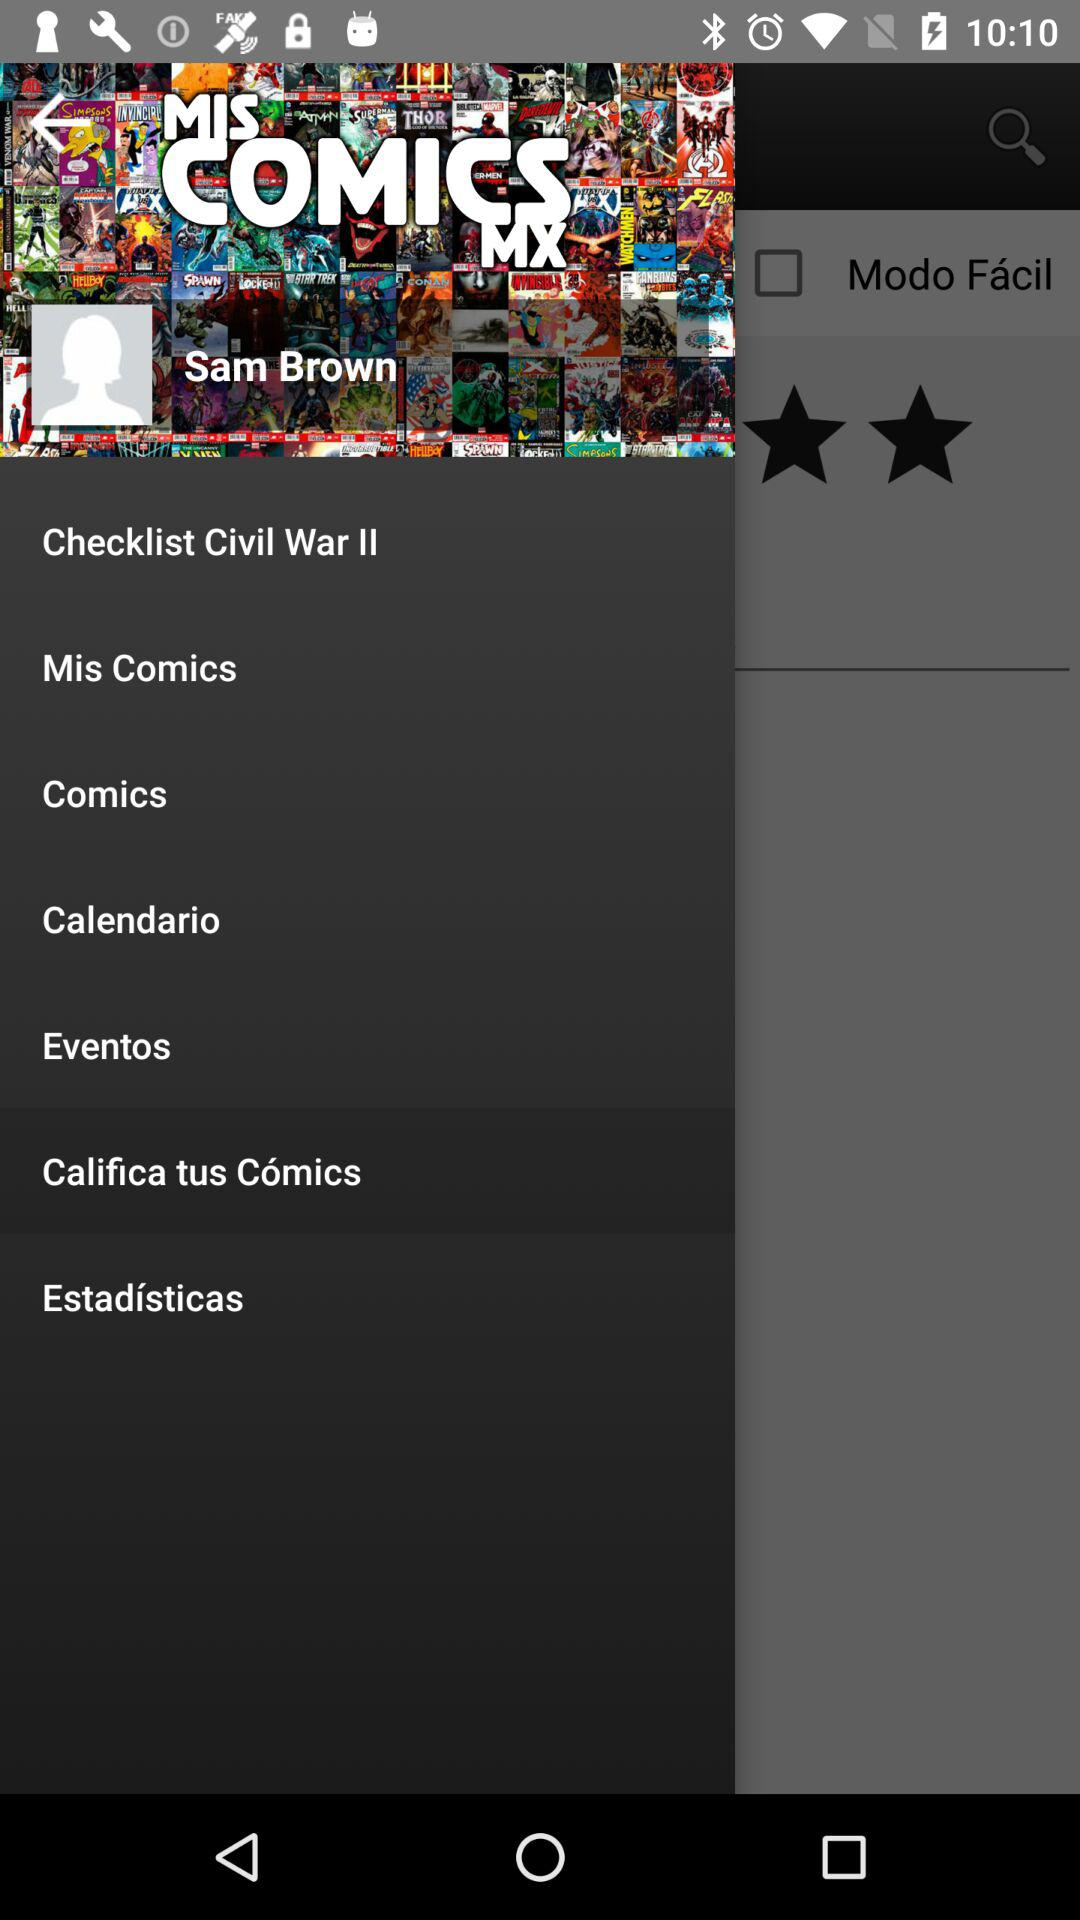What is the name of the application? The application name is "MIS COMICS MX". 